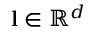<formula> <loc_0><loc_0><loc_500><loc_500>l \in \mathbb { R } ^ { d }</formula> 